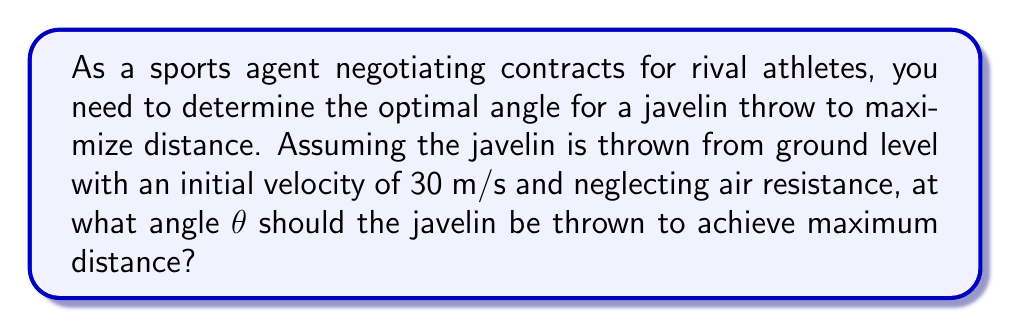Can you solve this math problem? To solve this problem, we'll follow these steps:

1) The trajectory of a projectile (like a javelin) is described by the equations:

   $$x = v_0 \cos(\theta) \cdot t$$
   $$y = v_0 \sin(\theta) \cdot t - \frac{1}{2}gt^2$$

   Where $v_0$ is the initial velocity, $\theta$ is the launch angle, $t$ is time, and $g$ is the acceleration due to gravity (9.8 m/s²).

2) The time of flight can be found when $y = 0$ at the end of the trajectory:

   $$0 = v_0 \sin(\theta) \cdot t - \frac{1}{2}gt^2$$

3) Solving for $t$:

   $$t = \frac{2v_0 \sin(\theta)}{g}$$

4) Substituting this into the equation for $x$ gives the range $R$:

   $$R = v_0 \cos(\theta) \cdot \frac{2v_0 \sin(\theta)}{g} = \frac{2v_0^2 \sin(\theta) \cos(\theta)}{g}$$

5) Using the trigonometric identity $\sin(2\theta) = 2\sin(\theta)\cos(\theta)$, we get:

   $$R = \frac{v_0^2 \sin(2\theta)}{g}$$

6) To maximize $R$, we need to maximize $\sin(2\theta)$. The maximum value of sine is 1, which occurs when its argument is 90°.

7) Therefore, $2\theta = 90°$, or $\theta = 45°$.

This result is independent of the initial velocity, as long as air resistance is neglected.
Answer: 45° 